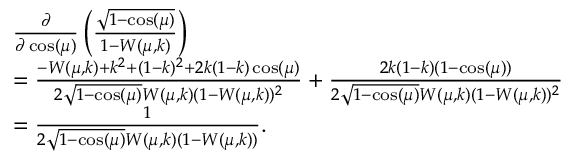<formula> <loc_0><loc_0><loc_500><loc_500>\begin{array} { r l } & { \frac { \partial } { \partial \cos ( \mu ) } \left ( \frac { \sqrt { 1 - \cos ( \mu ) } } { 1 - W ( \mu , k ) } \right ) } \\ & { = \frac { - W ( \mu , k ) + k ^ { 2 } + ( 1 - k ) ^ { 2 } + 2 k ( 1 - k ) \cos ( \mu ) } { 2 \sqrt { 1 - \cos ( \mu ) } W ( \mu , k ) ( 1 - W ( \mu , k ) ) ^ { 2 } } + \frac { 2 k ( 1 - k ) ( 1 - \cos ( \mu ) ) } { 2 \sqrt { 1 - \cos ( \mu ) } W ( \mu , k ) ( 1 - W ( \mu , k ) ) ^ { 2 } } } \\ & { = \frac { 1 } { 2 \sqrt { 1 - \cos ( \mu ) } W ( \mu , k ) ( 1 - W ( \mu , k ) ) } . } \end{array}</formula> 